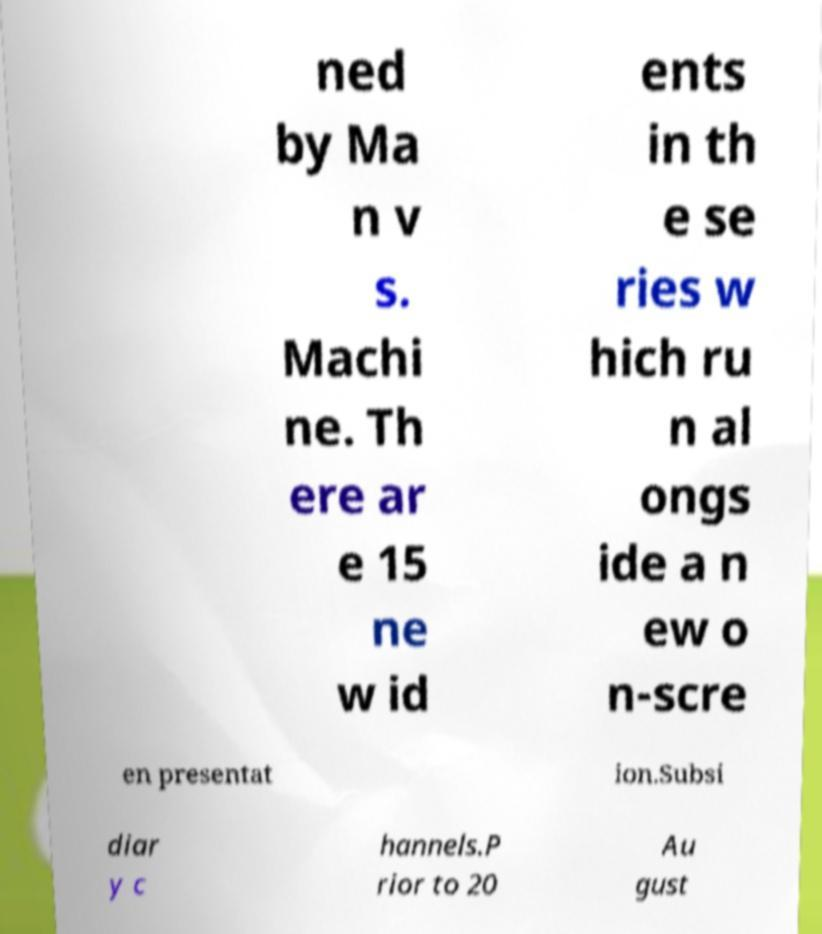Can you read and provide the text displayed in the image?This photo seems to have some interesting text. Can you extract and type it out for me? ned by Ma n v s. Machi ne. Th ere ar e 15 ne w id ents in th e se ries w hich ru n al ongs ide a n ew o n-scre en presentat ion.Subsi diar y c hannels.P rior to 20 Au gust 